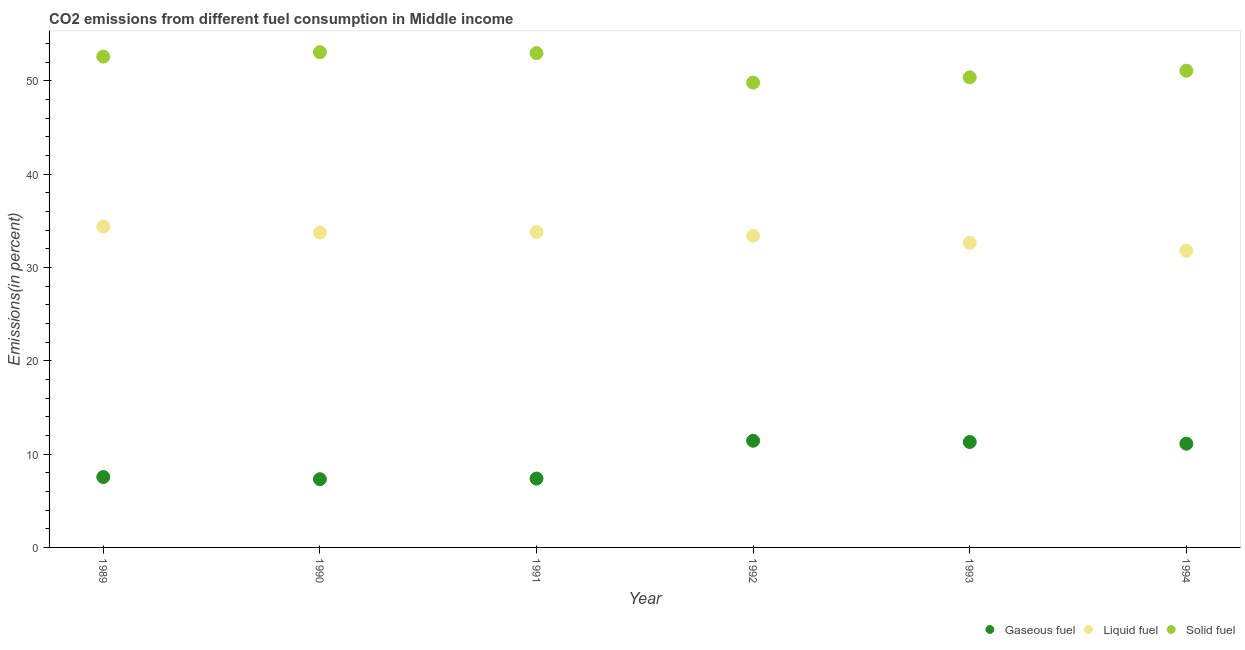How many different coloured dotlines are there?
Offer a terse response. 3. Is the number of dotlines equal to the number of legend labels?
Make the answer very short. Yes. What is the percentage of solid fuel emission in 1989?
Offer a terse response. 52.58. Across all years, what is the maximum percentage of liquid fuel emission?
Make the answer very short. 34.37. Across all years, what is the minimum percentage of gaseous fuel emission?
Your response must be concise. 7.31. In which year was the percentage of gaseous fuel emission maximum?
Give a very brief answer. 1992. In which year was the percentage of solid fuel emission minimum?
Make the answer very short. 1992. What is the total percentage of liquid fuel emission in the graph?
Your answer should be compact. 199.7. What is the difference between the percentage of solid fuel emission in 1989 and that in 1992?
Provide a short and direct response. 2.79. What is the difference between the percentage of gaseous fuel emission in 1993 and the percentage of liquid fuel emission in 1992?
Give a very brief answer. -22.09. What is the average percentage of liquid fuel emission per year?
Your answer should be compact. 33.28. In the year 1990, what is the difference between the percentage of liquid fuel emission and percentage of solid fuel emission?
Provide a short and direct response. -19.31. What is the ratio of the percentage of solid fuel emission in 1990 to that in 1991?
Keep it short and to the point. 1. Is the percentage of solid fuel emission in 1993 less than that in 1994?
Keep it short and to the point. Yes. Is the difference between the percentage of liquid fuel emission in 1990 and 1993 greater than the difference between the percentage of gaseous fuel emission in 1990 and 1993?
Ensure brevity in your answer.  Yes. What is the difference between the highest and the second highest percentage of liquid fuel emission?
Make the answer very short. 0.59. What is the difference between the highest and the lowest percentage of liquid fuel emission?
Offer a terse response. 2.59. Is the sum of the percentage of solid fuel emission in 1991 and 1992 greater than the maximum percentage of gaseous fuel emission across all years?
Keep it short and to the point. Yes. Is the percentage of liquid fuel emission strictly greater than the percentage of gaseous fuel emission over the years?
Offer a terse response. Yes. Is the percentage of solid fuel emission strictly less than the percentage of gaseous fuel emission over the years?
Provide a succinct answer. No. How many dotlines are there?
Your answer should be compact. 3. How many years are there in the graph?
Give a very brief answer. 6. What is the difference between two consecutive major ticks on the Y-axis?
Ensure brevity in your answer.  10. Where does the legend appear in the graph?
Your answer should be very brief. Bottom right. How many legend labels are there?
Your answer should be very brief. 3. What is the title of the graph?
Your answer should be very brief. CO2 emissions from different fuel consumption in Middle income. Does "Ireland" appear as one of the legend labels in the graph?
Keep it short and to the point. No. What is the label or title of the Y-axis?
Provide a short and direct response. Emissions(in percent). What is the Emissions(in percent) in Gaseous fuel in 1989?
Ensure brevity in your answer.  7.55. What is the Emissions(in percent) of Liquid fuel in 1989?
Keep it short and to the point. 34.37. What is the Emissions(in percent) of Solid fuel in 1989?
Offer a very short reply. 52.58. What is the Emissions(in percent) in Gaseous fuel in 1990?
Make the answer very short. 7.31. What is the Emissions(in percent) in Liquid fuel in 1990?
Your answer should be very brief. 33.74. What is the Emissions(in percent) in Solid fuel in 1990?
Give a very brief answer. 53.05. What is the Emissions(in percent) in Gaseous fuel in 1991?
Keep it short and to the point. 7.38. What is the Emissions(in percent) of Liquid fuel in 1991?
Keep it short and to the point. 33.79. What is the Emissions(in percent) of Solid fuel in 1991?
Offer a terse response. 52.95. What is the Emissions(in percent) in Gaseous fuel in 1992?
Your response must be concise. 11.43. What is the Emissions(in percent) of Liquid fuel in 1992?
Your answer should be very brief. 33.38. What is the Emissions(in percent) in Solid fuel in 1992?
Your answer should be compact. 49.8. What is the Emissions(in percent) in Gaseous fuel in 1993?
Provide a succinct answer. 11.3. What is the Emissions(in percent) in Liquid fuel in 1993?
Provide a short and direct response. 32.63. What is the Emissions(in percent) in Solid fuel in 1993?
Keep it short and to the point. 50.36. What is the Emissions(in percent) in Gaseous fuel in 1994?
Provide a short and direct response. 11.11. What is the Emissions(in percent) of Liquid fuel in 1994?
Ensure brevity in your answer.  31.78. What is the Emissions(in percent) of Solid fuel in 1994?
Provide a short and direct response. 51.07. Across all years, what is the maximum Emissions(in percent) of Gaseous fuel?
Ensure brevity in your answer.  11.43. Across all years, what is the maximum Emissions(in percent) of Liquid fuel?
Offer a very short reply. 34.37. Across all years, what is the maximum Emissions(in percent) of Solid fuel?
Your answer should be very brief. 53.05. Across all years, what is the minimum Emissions(in percent) of Gaseous fuel?
Provide a short and direct response. 7.31. Across all years, what is the minimum Emissions(in percent) of Liquid fuel?
Provide a succinct answer. 31.78. Across all years, what is the minimum Emissions(in percent) of Solid fuel?
Give a very brief answer. 49.8. What is the total Emissions(in percent) of Gaseous fuel in the graph?
Ensure brevity in your answer.  56.07. What is the total Emissions(in percent) of Liquid fuel in the graph?
Provide a short and direct response. 199.7. What is the total Emissions(in percent) in Solid fuel in the graph?
Provide a short and direct response. 309.82. What is the difference between the Emissions(in percent) of Gaseous fuel in 1989 and that in 1990?
Your answer should be very brief. 0.24. What is the difference between the Emissions(in percent) of Liquid fuel in 1989 and that in 1990?
Offer a very short reply. 0.63. What is the difference between the Emissions(in percent) in Solid fuel in 1989 and that in 1990?
Provide a succinct answer. -0.47. What is the difference between the Emissions(in percent) in Gaseous fuel in 1989 and that in 1991?
Keep it short and to the point. 0.17. What is the difference between the Emissions(in percent) of Liquid fuel in 1989 and that in 1991?
Offer a very short reply. 0.59. What is the difference between the Emissions(in percent) of Solid fuel in 1989 and that in 1991?
Your response must be concise. -0.37. What is the difference between the Emissions(in percent) in Gaseous fuel in 1989 and that in 1992?
Give a very brief answer. -3.88. What is the difference between the Emissions(in percent) in Liquid fuel in 1989 and that in 1992?
Provide a short and direct response. 0.99. What is the difference between the Emissions(in percent) in Solid fuel in 1989 and that in 1992?
Offer a very short reply. 2.79. What is the difference between the Emissions(in percent) in Gaseous fuel in 1989 and that in 1993?
Offer a terse response. -3.75. What is the difference between the Emissions(in percent) of Liquid fuel in 1989 and that in 1993?
Offer a terse response. 1.74. What is the difference between the Emissions(in percent) in Solid fuel in 1989 and that in 1993?
Make the answer very short. 2.22. What is the difference between the Emissions(in percent) in Gaseous fuel in 1989 and that in 1994?
Your answer should be compact. -3.57. What is the difference between the Emissions(in percent) in Liquid fuel in 1989 and that in 1994?
Your response must be concise. 2.59. What is the difference between the Emissions(in percent) in Solid fuel in 1989 and that in 1994?
Provide a short and direct response. 1.51. What is the difference between the Emissions(in percent) in Gaseous fuel in 1990 and that in 1991?
Your response must be concise. -0.07. What is the difference between the Emissions(in percent) of Liquid fuel in 1990 and that in 1991?
Offer a terse response. -0.05. What is the difference between the Emissions(in percent) of Solid fuel in 1990 and that in 1991?
Give a very brief answer. 0.1. What is the difference between the Emissions(in percent) in Gaseous fuel in 1990 and that in 1992?
Provide a short and direct response. -4.12. What is the difference between the Emissions(in percent) of Liquid fuel in 1990 and that in 1992?
Your answer should be compact. 0.36. What is the difference between the Emissions(in percent) of Solid fuel in 1990 and that in 1992?
Keep it short and to the point. 3.26. What is the difference between the Emissions(in percent) in Gaseous fuel in 1990 and that in 1993?
Your answer should be compact. -3.99. What is the difference between the Emissions(in percent) of Liquid fuel in 1990 and that in 1993?
Ensure brevity in your answer.  1.11. What is the difference between the Emissions(in percent) of Solid fuel in 1990 and that in 1993?
Your response must be concise. 2.69. What is the difference between the Emissions(in percent) in Gaseous fuel in 1990 and that in 1994?
Ensure brevity in your answer.  -3.8. What is the difference between the Emissions(in percent) of Liquid fuel in 1990 and that in 1994?
Keep it short and to the point. 1.95. What is the difference between the Emissions(in percent) in Solid fuel in 1990 and that in 1994?
Offer a very short reply. 1.98. What is the difference between the Emissions(in percent) in Gaseous fuel in 1991 and that in 1992?
Keep it short and to the point. -4.05. What is the difference between the Emissions(in percent) in Liquid fuel in 1991 and that in 1992?
Provide a short and direct response. 0.41. What is the difference between the Emissions(in percent) of Solid fuel in 1991 and that in 1992?
Offer a terse response. 3.16. What is the difference between the Emissions(in percent) of Gaseous fuel in 1991 and that in 1993?
Keep it short and to the point. -3.92. What is the difference between the Emissions(in percent) of Liquid fuel in 1991 and that in 1993?
Provide a succinct answer. 1.16. What is the difference between the Emissions(in percent) of Solid fuel in 1991 and that in 1993?
Offer a terse response. 2.59. What is the difference between the Emissions(in percent) in Gaseous fuel in 1991 and that in 1994?
Provide a short and direct response. -3.74. What is the difference between the Emissions(in percent) in Liquid fuel in 1991 and that in 1994?
Ensure brevity in your answer.  2. What is the difference between the Emissions(in percent) of Solid fuel in 1991 and that in 1994?
Make the answer very short. 1.88. What is the difference between the Emissions(in percent) of Gaseous fuel in 1992 and that in 1993?
Offer a terse response. 0.13. What is the difference between the Emissions(in percent) of Liquid fuel in 1992 and that in 1993?
Your response must be concise. 0.75. What is the difference between the Emissions(in percent) of Solid fuel in 1992 and that in 1993?
Give a very brief answer. -0.57. What is the difference between the Emissions(in percent) in Gaseous fuel in 1992 and that in 1994?
Offer a very short reply. 0.32. What is the difference between the Emissions(in percent) in Liquid fuel in 1992 and that in 1994?
Keep it short and to the point. 1.6. What is the difference between the Emissions(in percent) of Solid fuel in 1992 and that in 1994?
Provide a short and direct response. -1.27. What is the difference between the Emissions(in percent) of Gaseous fuel in 1993 and that in 1994?
Provide a short and direct response. 0.18. What is the difference between the Emissions(in percent) in Liquid fuel in 1993 and that in 1994?
Your answer should be compact. 0.84. What is the difference between the Emissions(in percent) in Solid fuel in 1993 and that in 1994?
Provide a succinct answer. -0.71. What is the difference between the Emissions(in percent) of Gaseous fuel in 1989 and the Emissions(in percent) of Liquid fuel in 1990?
Offer a very short reply. -26.19. What is the difference between the Emissions(in percent) of Gaseous fuel in 1989 and the Emissions(in percent) of Solid fuel in 1990?
Give a very brief answer. -45.51. What is the difference between the Emissions(in percent) in Liquid fuel in 1989 and the Emissions(in percent) in Solid fuel in 1990?
Provide a short and direct response. -18.68. What is the difference between the Emissions(in percent) in Gaseous fuel in 1989 and the Emissions(in percent) in Liquid fuel in 1991?
Offer a terse response. -26.24. What is the difference between the Emissions(in percent) in Gaseous fuel in 1989 and the Emissions(in percent) in Solid fuel in 1991?
Provide a short and direct response. -45.41. What is the difference between the Emissions(in percent) in Liquid fuel in 1989 and the Emissions(in percent) in Solid fuel in 1991?
Provide a succinct answer. -18.58. What is the difference between the Emissions(in percent) of Gaseous fuel in 1989 and the Emissions(in percent) of Liquid fuel in 1992?
Your answer should be very brief. -25.84. What is the difference between the Emissions(in percent) of Gaseous fuel in 1989 and the Emissions(in percent) of Solid fuel in 1992?
Your answer should be compact. -42.25. What is the difference between the Emissions(in percent) in Liquid fuel in 1989 and the Emissions(in percent) in Solid fuel in 1992?
Offer a terse response. -15.42. What is the difference between the Emissions(in percent) of Gaseous fuel in 1989 and the Emissions(in percent) of Liquid fuel in 1993?
Keep it short and to the point. -25.08. What is the difference between the Emissions(in percent) of Gaseous fuel in 1989 and the Emissions(in percent) of Solid fuel in 1993?
Make the answer very short. -42.82. What is the difference between the Emissions(in percent) in Liquid fuel in 1989 and the Emissions(in percent) in Solid fuel in 1993?
Provide a short and direct response. -15.99. What is the difference between the Emissions(in percent) of Gaseous fuel in 1989 and the Emissions(in percent) of Liquid fuel in 1994?
Offer a very short reply. -24.24. What is the difference between the Emissions(in percent) in Gaseous fuel in 1989 and the Emissions(in percent) in Solid fuel in 1994?
Ensure brevity in your answer.  -43.52. What is the difference between the Emissions(in percent) of Liquid fuel in 1989 and the Emissions(in percent) of Solid fuel in 1994?
Offer a terse response. -16.7. What is the difference between the Emissions(in percent) of Gaseous fuel in 1990 and the Emissions(in percent) of Liquid fuel in 1991?
Offer a terse response. -26.48. What is the difference between the Emissions(in percent) of Gaseous fuel in 1990 and the Emissions(in percent) of Solid fuel in 1991?
Provide a short and direct response. -45.64. What is the difference between the Emissions(in percent) of Liquid fuel in 1990 and the Emissions(in percent) of Solid fuel in 1991?
Ensure brevity in your answer.  -19.21. What is the difference between the Emissions(in percent) in Gaseous fuel in 1990 and the Emissions(in percent) in Liquid fuel in 1992?
Provide a short and direct response. -26.07. What is the difference between the Emissions(in percent) of Gaseous fuel in 1990 and the Emissions(in percent) of Solid fuel in 1992?
Your answer should be very brief. -42.49. What is the difference between the Emissions(in percent) in Liquid fuel in 1990 and the Emissions(in percent) in Solid fuel in 1992?
Make the answer very short. -16.06. What is the difference between the Emissions(in percent) of Gaseous fuel in 1990 and the Emissions(in percent) of Liquid fuel in 1993?
Provide a short and direct response. -25.32. What is the difference between the Emissions(in percent) of Gaseous fuel in 1990 and the Emissions(in percent) of Solid fuel in 1993?
Offer a terse response. -43.05. What is the difference between the Emissions(in percent) of Liquid fuel in 1990 and the Emissions(in percent) of Solid fuel in 1993?
Ensure brevity in your answer.  -16.62. What is the difference between the Emissions(in percent) of Gaseous fuel in 1990 and the Emissions(in percent) of Liquid fuel in 1994?
Your answer should be very brief. -24.48. What is the difference between the Emissions(in percent) of Gaseous fuel in 1990 and the Emissions(in percent) of Solid fuel in 1994?
Give a very brief answer. -43.76. What is the difference between the Emissions(in percent) in Liquid fuel in 1990 and the Emissions(in percent) in Solid fuel in 1994?
Your answer should be very brief. -17.33. What is the difference between the Emissions(in percent) in Gaseous fuel in 1991 and the Emissions(in percent) in Liquid fuel in 1992?
Ensure brevity in your answer.  -26.01. What is the difference between the Emissions(in percent) in Gaseous fuel in 1991 and the Emissions(in percent) in Solid fuel in 1992?
Offer a terse response. -42.42. What is the difference between the Emissions(in percent) in Liquid fuel in 1991 and the Emissions(in percent) in Solid fuel in 1992?
Make the answer very short. -16.01. What is the difference between the Emissions(in percent) in Gaseous fuel in 1991 and the Emissions(in percent) in Liquid fuel in 1993?
Offer a very short reply. -25.25. What is the difference between the Emissions(in percent) of Gaseous fuel in 1991 and the Emissions(in percent) of Solid fuel in 1993?
Your answer should be very brief. -42.98. What is the difference between the Emissions(in percent) of Liquid fuel in 1991 and the Emissions(in percent) of Solid fuel in 1993?
Your answer should be compact. -16.57. What is the difference between the Emissions(in percent) of Gaseous fuel in 1991 and the Emissions(in percent) of Liquid fuel in 1994?
Provide a succinct answer. -24.41. What is the difference between the Emissions(in percent) of Gaseous fuel in 1991 and the Emissions(in percent) of Solid fuel in 1994?
Provide a succinct answer. -43.69. What is the difference between the Emissions(in percent) in Liquid fuel in 1991 and the Emissions(in percent) in Solid fuel in 1994?
Your answer should be compact. -17.28. What is the difference between the Emissions(in percent) of Gaseous fuel in 1992 and the Emissions(in percent) of Liquid fuel in 1993?
Offer a terse response. -21.2. What is the difference between the Emissions(in percent) of Gaseous fuel in 1992 and the Emissions(in percent) of Solid fuel in 1993?
Give a very brief answer. -38.93. What is the difference between the Emissions(in percent) in Liquid fuel in 1992 and the Emissions(in percent) in Solid fuel in 1993?
Keep it short and to the point. -16.98. What is the difference between the Emissions(in percent) in Gaseous fuel in 1992 and the Emissions(in percent) in Liquid fuel in 1994?
Provide a short and direct response. -20.35. What is the difference between the Emissions(in percent) of Gaseous fuel in 1992 and the Emissions(in percent) of Solid fuel in 1994?
Provide a short and direct response. -39.64. What is the difference between the Emissions(in percent) of Liquid fuel in 1992 and the Emissions(in percent) of Solid fuel in 1994?
Your answer should be very brief. -17.69. What is the difference between the Emissions(in percent) of Gaseous fuel in 1993 and the Emissions(in percent) of Liquid fuel in 1994?
Provide a short and direct response. -20.49. What is the difference between the Emissions(in percent) of Gaseous fuel in 1993 and the Emissions(in percent) of Solid fuel in 1994?
Make the answer very short. -39.77. What is the difference between the Emissions(in percent) in Liquid fuel in 1993 and the Emissions(in percent) in Solid fuel in 1994?
Offer a terse response. -18.44. What is the average Emissions(in percent) of Gaseous fuel per year?
Your response must be concise. 9.34. What is the average Emissions(in percent) in Liquid fuel per year?
Give a very brief answer. 33.28. What is the average Emissions(in percent) in Solid fuel per year?
Keep it short and to the point. 51.64. In the year 1989, what is the difference between the Emissions(in percent) of Gaseous fuel and Emissions(in percent) of Liquid fuel?
Provide a succinct answer. -26.83. In the year 1989, what is the difference between the Emissions(in percent) of Gaseous fuel and Emissions(in percent) of Solid fuel?
Offer a very short reply. -45.04. In the year 1989, what is the difference between the Emissions(in percent) of Liquid fuel and Emissions(in percent) of Solid fuel?
Provide a short and direct response. -18.21. In the year 1990, what is the difference between the Emissions(in percent) in Gaseous fuel and Emissions(in percent) in Liquid fuel?
Provide a succinct answer. -26.43. In the year 1990, what is the difference between the Emissions(in percent) of Gaseous fuel and Emissions(in percent) of Solid fuel?
Ensure brevity in your answer.  -45.74. In the year 1990, what is the difference between the Emissions(in percent) of Liquid fuel and Emissions(in percent) of Solid fuel?
Your answer should be very brief. -19.31. In the year 1991, what is the difference between the Emissions(in percent) of Gaseous fuel and Emissions(in percent) of Liquid fuel?
Keep it short and to the point. -26.41. In the year 1991, what is the difference between the Emissions(in percent) in Gaseous fuel and Emissions(in percent) in Solid fuel?
Your response must be concise. -45.58. In the year 1991, what is the difference between the Emissions(in percent) in Liquid fuel and Emissions(in percent) in Solid fuel?
Your answer should be compact. -19.17. In the year 1992, what is the difference between the Emissions(in percent) of Gaseous fuel and Emissions(in percent) of Liquid fuel?
Ensure brevity in your answer.  -21.95. In the year 1992, what is the difference between the Emissions(in percent) of Gaseous fuel and Emissions(in percent) of Solid fuel?
Your answer should be very brief. -38.37. In the year 1992, what is the difference between the Emissions(in percent) in Liquid fuel and Emissions(in percent) in Solid fuel?
Your answer should be compact. -16.41. In the year 1993, what is the difference between the Emissions(in percent) of Gaseous fuel and Emissions(in percent) of Liquid fuel?
Provide a succinct answer. -21.33. In the year 1993, what is the difference between the Emissions(in percent) in Gaseous fuel and Emissions(in percent) in Solid fuel?
Your answer should be very brief. -39.07. In the year 1993, what is the difference between the Emissions(in percent) in Liquid fuel and Emissions(in percent) in Solid fuel?
Make the answer very short. -17.73. In the year 1994, what is the difference between the Emissions(in percent) of Gaseous fuel and Emissions(in percent) of Liquid fuel?
Provide a succinct answer. -20.67. In the year 1994, what is the difference between the Emissions(in percent) in Gaseous fuel and Emissions(in percent) in Solid fuel?
Your response must be concise. -39.96. In the year 1994, what is the difference between the Emissions(in percent) in Liquid fuel and Emissions(in percent) in Solid fuel?
Offer a very short reply. -19.29. What is the ratio of the Emissions(in percent) in Gaseous fuel in 1989 to that in 1990?
Offer a very short reply. 1.03. What is the ratio of the Emissions(in percent) in Liquid fuel in 1989 to that in 1990?
Provide a short and direct response. 1.02. What is the ratio of the Emissions(in percent) in Solid fuel in 1989 to that in 1990?
Your answer should be compact. 0.99. What is the ratio of the Emissions(in percent) in Gaseous fuel in 1989 to that in 1991?
Ensure brevity in your answer.  1.02. What is the ratio of the Emissions(in percent) in Liquid fuel in 1989 to that in 1991?
Make the answer very short. 1.02. What is the ratio of the Emissions(in percent) in Gaseous fuel in 1989 to that in 1992?
Give a very brief answer. 0.66. What is the ratio of the Emissions(in percent) in Liquid fuel in 1989 to that in 1992?
Provide a succinct answer. 1.03. What is the ratio of the Emissions(in percent) of Solid fuel in 1989 to that in 1992?
Provide a succinct answer. 1.06. What is the ratio of the Emissions(in percent) of Gaseous fuel in 1989 to that in 1993?
Offer a very short reply. 0.67. What is the ratio of the Emissions(in percent) in Liquid fuel in 1989 to that in 1993?
Your answer should be very brief. 1.05. What is the ratio of the Emissions(in percent) of Solid fuel in 1989 to that in 1993?
Your response must be concise. 1.04. What is the ratio of the Emissions(in percent) of Gaseous fuel in 1989 to that in 1994?
Give a very brief answer. 0.68. What is the ratio of the Emissions(in percent) in Liquid fuel in 1989 to that in 1994?
Offer a terse response. 1.08. What is the ratio of the Emissions(in percent) in Solid fuel in 1989 to that in 1994?
Your answer should be compact. 1.03. What is the ratio of the Emissions(in percent) in Gaseous fuel in 1990 to that in 1991?
Keep it short and to the point. 0.99. What is the ratio of the Emissions(in percent) in Solid fuel in 1990 to that in 1991?
Make the answer very short. 1. What is the ratio of the Emissions(in percent) of Gaseous fuel in 1990 to that in 1992?
Your answer should be compact. 0.64. What is the ratio of the Emissions(in percent) in Liquid fuel in 1990 to that in 1992?
Your response must be concise. 1.01. What is the ratio of the Emissions(in percent) in Solid fuel in 1990 to that in 1992?
Offer a terse response. 1.07. What is the ratio of the Emissions(in percent) of Gaseous fuel in 1990 to that in 1993?
Offer a terse response. 0.65. What is the ratio of the Emissions(in percent) in Liquid fuel in 1990 to that in 1993?
Offer a very short reply. 1.03. What is the ratio of the Emissions(in percent) of Solid fuel in 1990 to that in 1993?
Give a very brief answer. 1.05. What is the ratio of the Emissions(in percent) in Gaseous fuel in 1990 to that in 1994?
Offer a terse response. 0.66. What is the ratio of the Emissions(in percent) in Liquid fuel in 1990 to that in 1994?
Provide a short and direct response. 1.06. What is the ratio of the Emissions(in percent) of Solid fuel in 1990 to that in 1994?
Ensure brevity in your answer.  1.04. What is the ratio of the Emissions(in percent) in Gaseous fuel in 1991 to that in 1992?
Keep it short and to the point. 0.65. What is the ratio of the Emissions(in percent) in Liquid fuel in 1991 to that in 1992?
Keep it short and to the point. 1.01. What is the ratio of the Emissions(in percent) in Solid fuel in 1991 to that in 1992?
Offer a very short reply. 1.06. What is the ratio of the Emissions(in percent) in Gaseous fuel in 1991 to that in 1993?
Your response must be concise. 0.65. What is the ratio of the Emissions(in percent) of Liquid fuel in 1991 to that in 1993?
Provide a succinct answer. 1.04. What is the ratio of the Emissions(in percent) in Solid fuel in 1991 to that in 1993?
Provide a succinct answer. 1.05. What is the ratio of the Emissions(in percent) of Gaseous fuel in 1991 to that in 1994?
Provide a succinct answer. 0.66. What is the ratio of the Emissions(in percent) of Liquid fuel in 1991 to that in 1994?
Make the answer very short. 1.06. What is the ratio of the Emissions(in percent) of Solid fuel in 1991 to that in 1994?
Provide a succinct answer. 1.04. What is the ratio of the Emissions(in percent) in Gaseous fuel in 1992 to that in 1993?
Make the answer very short. 1.01. What is the ratio of the Emissions(in percent) in Liquid fuel in 1992 to that in 1993?
Ensure brevity in your answer.  1.02. What is the ratio of the Emissions(in percent) of Solid fuel in 1992 to that in 1993?
Your answer should be compact. 0.99. What is the ratio of the Emissions(in percent) of Gaseous fuel in 1992 to that in 1994?
Your answer should be very brief. 1.03. What is the ratio of the Emissions(in percent) of Liquid fuel in 1992 to that in 1994?
Keep it short and to the point. 1.05. What is the ratio of the Emissions(in percent) of Gaseous fuel in 1993 to that in 1994?
Give a very brief answer. 1.02. What is the ratio of the Emissions(in percent) in Liquid fuel in 1993 to that in 1994?
Your answer should be compact. 1.03. What is the ratio of the Emissions(in percent) in Solid fuel in 1993 to that in 1994?
Your answer should be very brief. 0.99. What is the difference between the highest and the second highest Emissions(in percent) of Gaseous fuel?
Offer a terse response. 0.13. What is the difference between the highest and the second highest Emissions(in percent) of Liquid fuel?
Keep it short and to the point. 0.59. What is the difference between the highest and the second highest Emissions(in percent) of Solid fuel?
Offer a very short reply. 0.1. What is the difference between the highest and the lowest Emissions(in percent) in Gaseous fuel?
Give a very brief answer. 4.12. What is the difference between the highest and the lowest Emissions(in percent) in Liquid fuel?
Your answer should be very brief. 2.59. What is the difference between the highest and the lowest Emissions(in percent) of Solid fuel?
Your answer should be very brief. 3.26. 